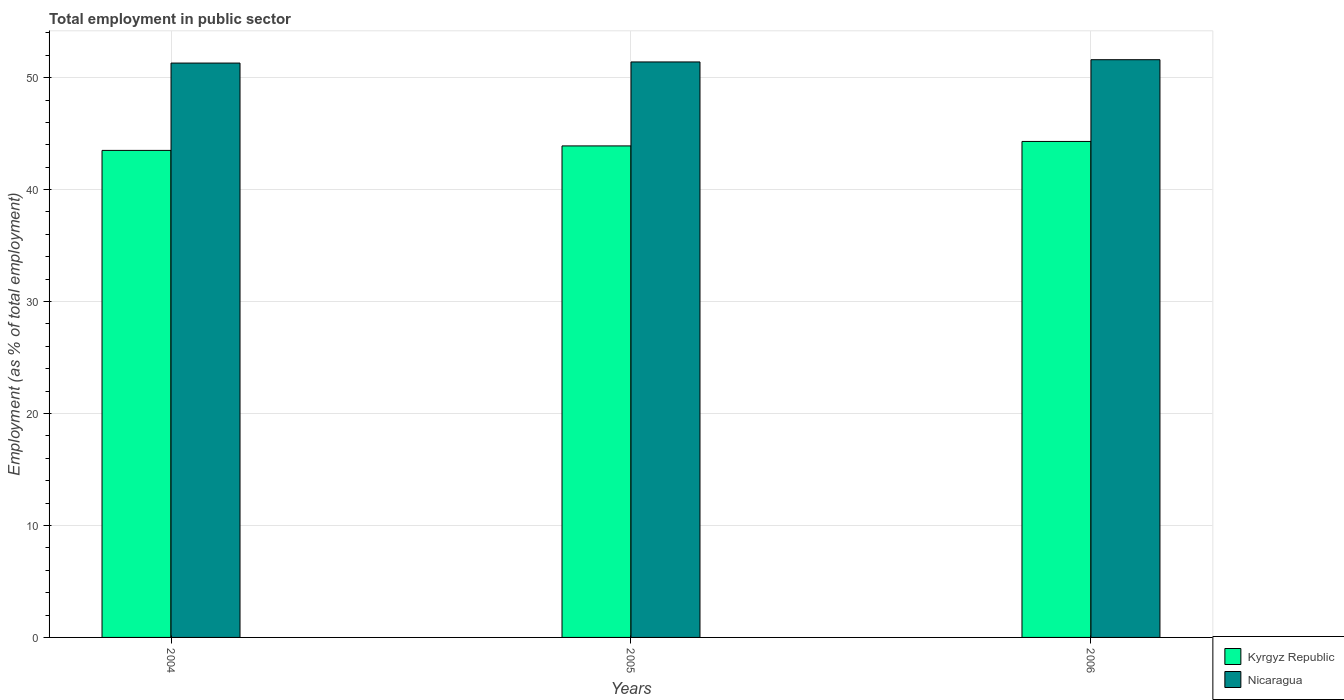How many different coloured bars are there?
Your response must be concise. 2. Are the number of bars on each tick of the X-axis equal?
Your answer should be compact. Yes. How many bars are there on the 3rd tick from the left?
Make the answer very short. 2. How many bars are there on the 3rd tick from the right?
Give a very brief answer. 2. What is the employment in public sector in Kyrgyz Republic in 2004?
Ensure brevity in your answer.  43.5. Across all years, what is the maximum employment in public sector in Nicaragua?
Provide a succinct answer. 51.6. Across all years, what is the minimum employment in public sector in Kyrgyz Republic?
Keep it short and to the point. 43.5. In which year was the employment in public sector in Nicaragua minimum?
Make the answer very short. 2004. What is the total employment in public sector in Nicaragua in the graph?
Your response must be concise. 154.3. What is the difference between the employment in public sector in Nicaragua in 2005 and that in 2006?
Provide a succinct answer. -0.2. What is the difference between the employment in public sector in Kyrgyz Republic in 2005 and the employment in public sector in Nicaragua in 2004?
Make the answer very short. -7.4. What is the average employment in public sector in Kyrgyz Republic per year?
Your answer should be very brief. 43.9. In the year 2004, what is the difference between the employment in public sector in Nicaragua and employment in public sector in Kyrgyz Republic?
Ensure brevity in your answer.  7.8. What is the ratio of the employment in public sector in Nicaragua in 2005 to that in 2006?
Your answer should be very brief. 1. Is the difference between the employment in public sector in Nicaragua in 2004 and 2005 greater than the difference between the employment in public sector in Kyrgyz Republic in 2004 and 2005?
Keep it short and to the point. Yes. What is the difference between the highest and the second highest employment in public sector in Kyrgyz Republic?
Provide a succinct answer. 0.4. What is the difference between the highest and the lowest employment in public sector in Kyrgyz Republic?
Your response must be concise. 0.8. In how many years, is the employment in public sector in Nicaragua greater than the average employment in public sector in Nicaragua taken over all years?
Provide a succinct answer. 1. Is the sum of the employment in public sector in Kyrgyz Republic in 2004 and 2005 greater than the maximum employment in public sector in Nicaragua across all years?
Your answer should be very brief. Yes. What does the 1st bar from the left in 2005 represents?
Make the answer very short. Kyrgyz Republic. What does the 1st bar from the right in 2004 represents?
Provide a succinct answer. Nicaragua. What is the difference between two consecutive major ticks on the Y-axis?
Keep it short and to the point. 10. Does the graph contain any zero values?
Your response must be concise. No. Does the graph contain grids?
Offer a very short reply. Yes. What is the title of the graph?
Your answer should be very brief. Total employment in public sector. Does "Indonesia" appear as one of the legend labels in the graph?
Provide a short and direct response. No. What is the label or title of the X-axis?
Offer a terse response. Years. What is the label or title of the Y-axis?
Provide a succinct answer. Employment (as % of total employment). What is the Employment (as % of total employment) of Kyrgyz Republic in 2004?
Your answer should be compact. 43.5. What is the Employment (as % of total employment) of Nicaragua in 2004?
Provide a succinct answer. 51.3. What is the Employment (as % of total employment) of Kyrgyz Republic in 2005?
Ensure brevity in your answer.  43.9. What is the Employment (as % of total employment) of Nicaragua in 2005?
Provide a short and direct response. 51.4. What is the Employment (as % of total employment) in Kyrgyz Republic in 2006?
Your answer should be very brief. 44.3. What is the Employment (as % of total employment) in Nicaragua in 2006?
Provide a succinct answer. 51.6. Across all years, what is the maximum Employment (as % of total employment) in Kyrgyz Republic?
Give a very brief answer. 44.3. Across all years, what is the maximum Employment (as % of total employment) of Nicaragua?
Provide a short and direct response. 51.6. Across all years, what is the minimum Employment (as % of total employment) of Kyrgyz Republic?
Ensure brevity in your answer.  43.5. Across all years, what is the minimum Employment (as % of total employment) of Nicaragua?
Ensure brevity in your answer.  51.3. What is the total Employment (as % of total employment) in Kyrgyz Republic in the graph?
Ensure brevity in your answer.  131.7. What is the total Employment (as % of total employment) in Nicaragua in the graph?
Your answer should be compact. 154.3. What is the difference between the Employment (as % of total employment) in Kyrgyz Republic in 2004 and that in 2006?
Your answer should be compact. -0.8. What is the difference between the Employment (as % of total employment) in Kyrgyz Republic in 2005 and that in 2006?
Offer a very short reply. -0.4. What is the difference between the Employment (as % of total employment) of Nicaragua in 2005 and that in 2006?
Ensure brevity in your answer.  -0.2. What is the difference between the Employment (as % of total employment) in Kyrgyz Republic in 2004 and the Employment (as % of total employment) in Nicaragua in 2005?
Your answer should be very brief. -7.9. What is the average Employment (as % of total employment) of Kyrgyz Republic per year?
Your answer should be compact. 43.9. What is the average Employment (as % of total employment) in Nicaragua per year?
Your answer should be very brief. 51.43. In the year 2005, what is the difference between the Employment (as % of total employment) of Kyrgyz Republic and Employment (as % of total employment) of Nicaragua?
Ensure brevity in your answer.  -7.5. What is the ratio of the Employment (as % of total employment) of Kyrgyz Republic in 2004 to that in 2005?
Your answer should be very brief. 0.99. What is the ratio of the Employment (as % of total employment) of Kyrgyz Republic in 2004 to that in 2006?
Ensure brevity in your answer.  0.98. What is the ratio of the Employment (as % of total employment) in Nicaragua in 2004 to that in 2006?
Offer a terse response. 0.99. What is the ratio of the Employment (as % of total employment) in Nicaragua in 2005 to that in 2006?
Ensure brevity in your answer.  1. What is the difference between the highest and the second highest Employment (as % of total employment) of Kyrgyz Republic?
Offer a terse response. 0.4. 